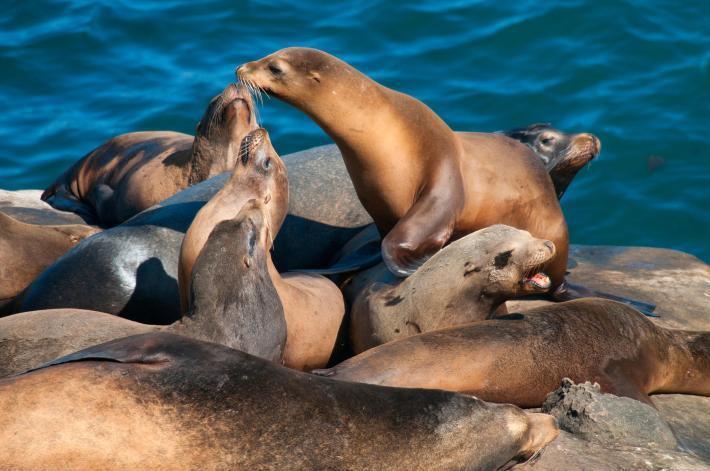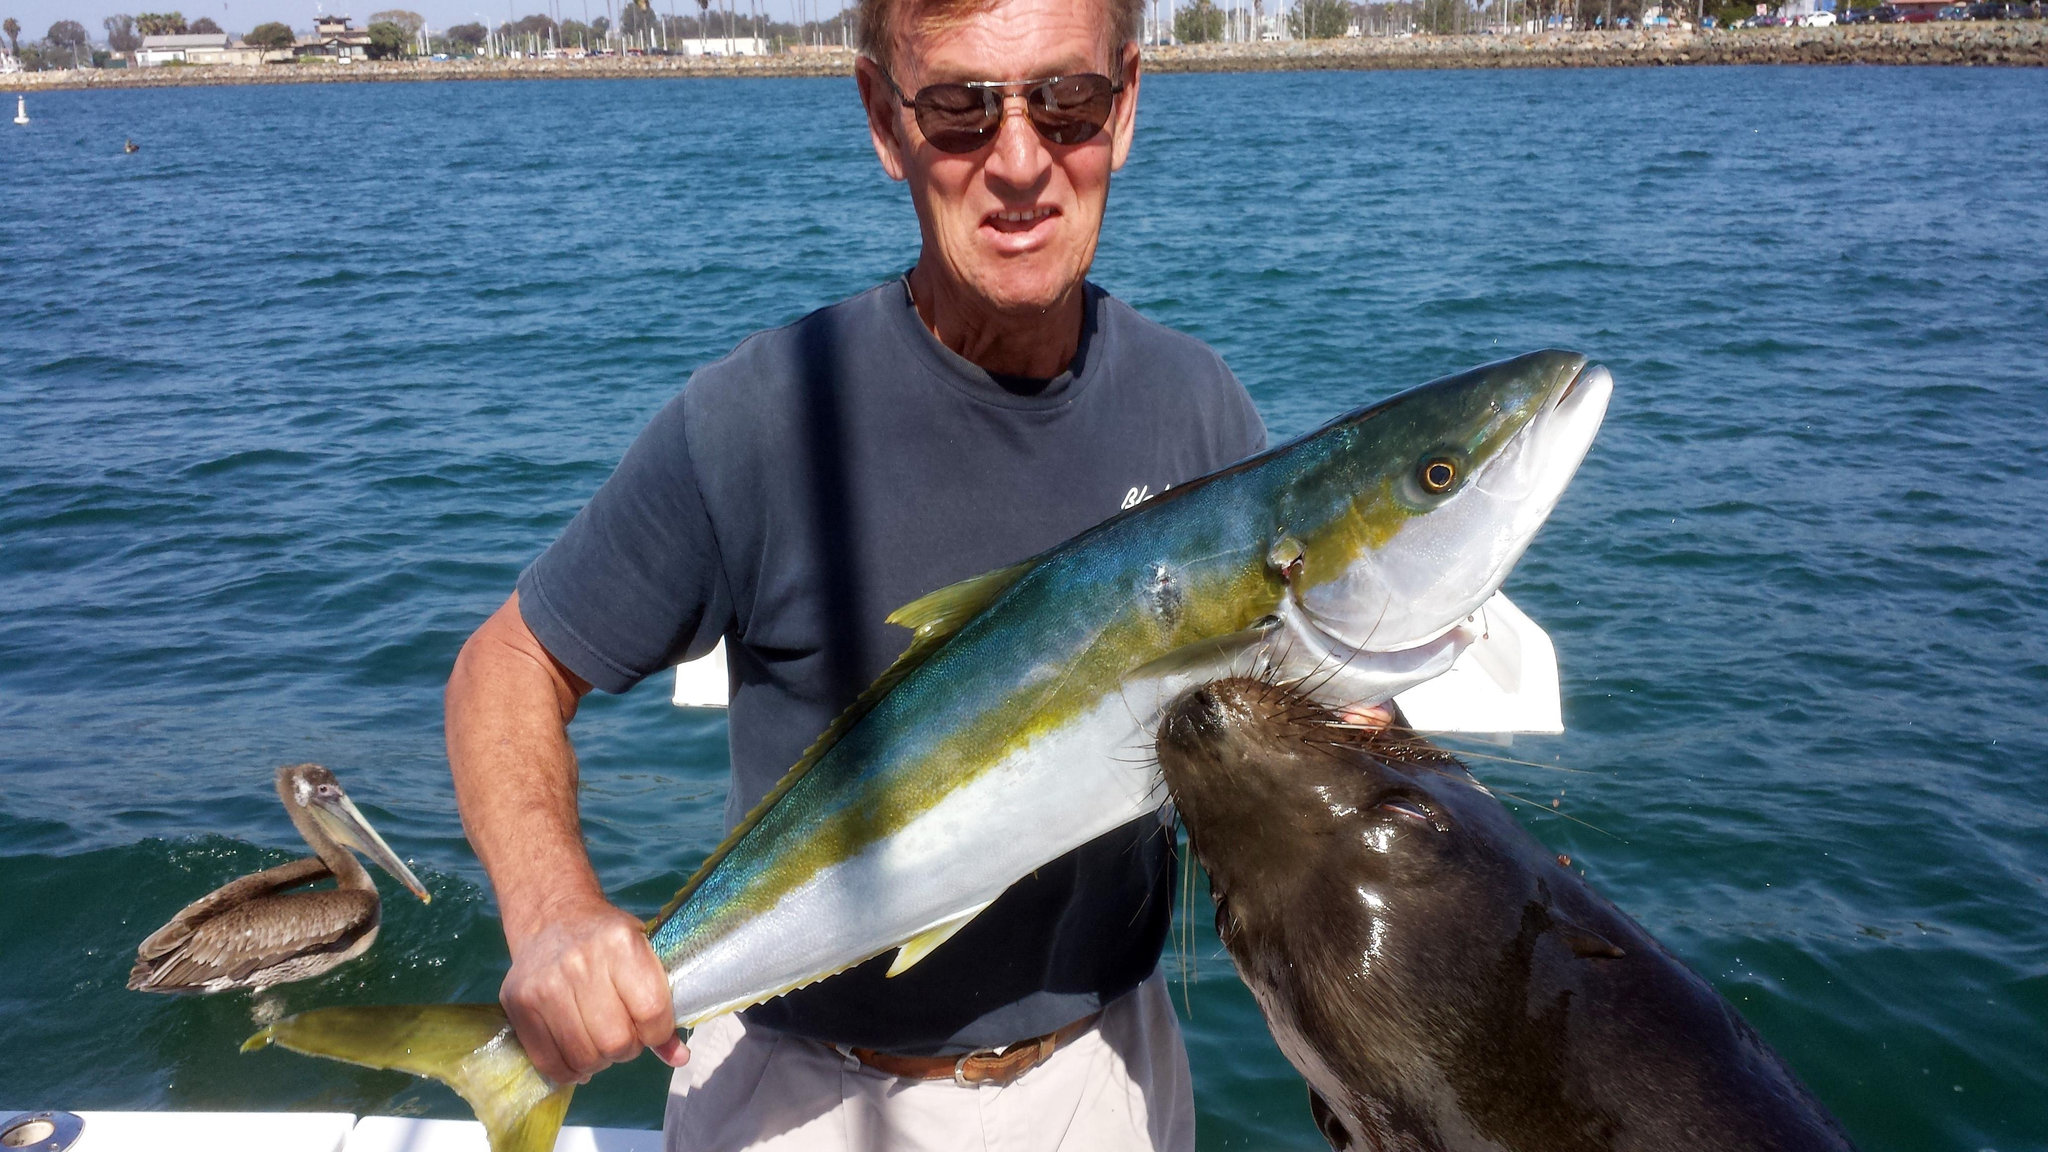The first image is the image on the left, the second image is the image on the right. Considering the images on both sides, is "At least one image includes human interaction with a seal." valid? Answer yes or no. Yes. 